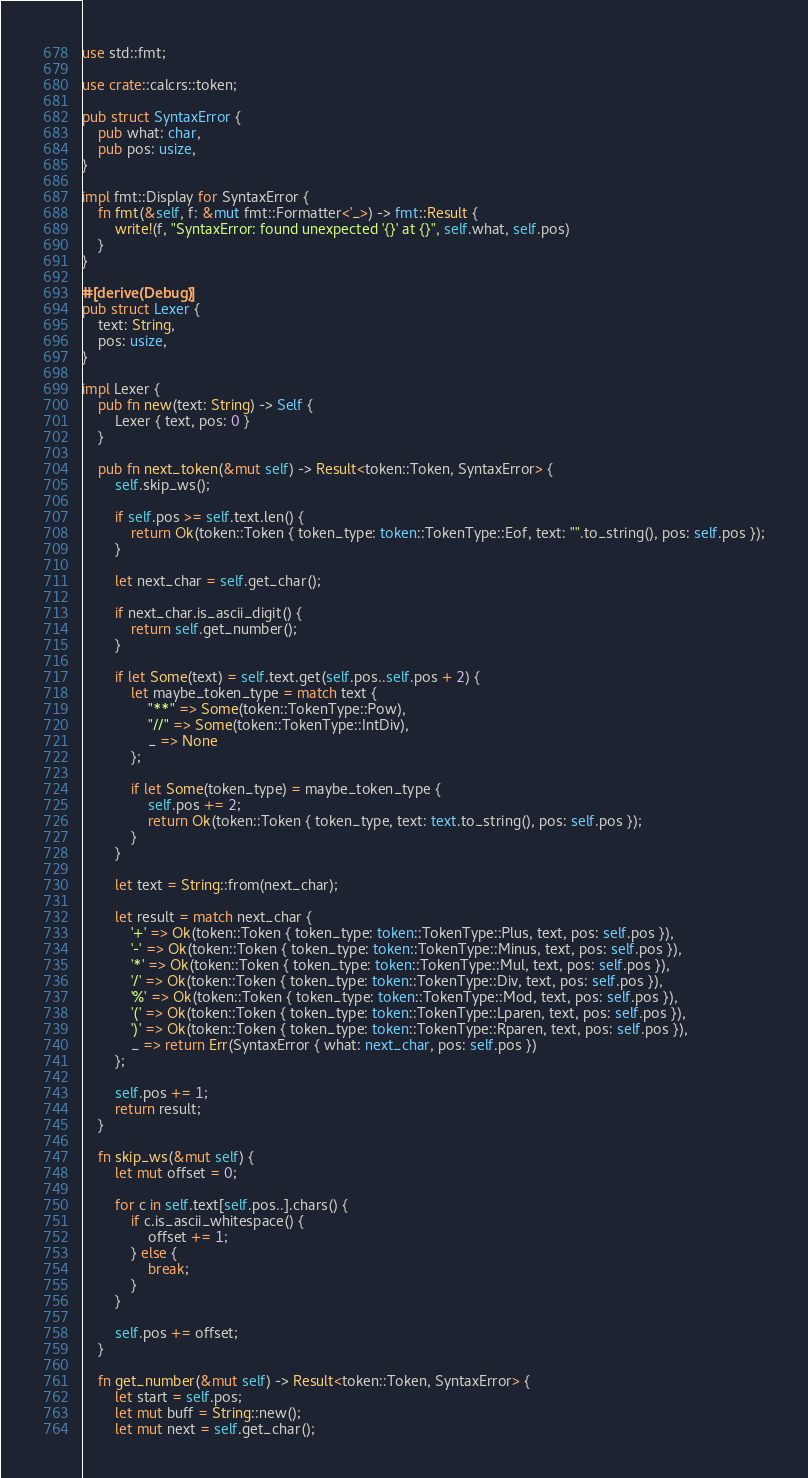Convert code to text. <code><loc_0><loc_0><loc_500><loc_500><_Rust_>use std::fmt;

use crate::calcrs::token;

pub struct SyntaxError {
    pub what: char,
    pub pos: usize,
}

impl fmt::Display for SyntaxError {
    fn fmt(&self, f: &mut fmt::Formatter<'_>) -> fmt::Result {
        write!(f, "SyntaxError: found unexpected '{}' at {}", self.what, self.pos)
    }
}

#[derive(Debug)]
pub struct Lexer {
    text: String,
    pos: usize,
}

impl Lexer {
    pub fn new(text: String) -> Self {
        Lexer { text, pos: 0 }
    }

    pub fn next_token(&mut self) -> Result<token::Token, SyntaxError> {
        self.skip_ws();

        if self.pos >= self.text.len() {
            return Ok(token::Token { token_type: token::TokenType::Eof, text: "".to_string(), pos: self.pos });
        }

        let next_char = self.get_char();

        if next_char.is_ascii_digit() {
            return self.get_number();
        }

        if let Some(text) = self.text.get(self.pos..self.pos + 2) {
            let maybe_token_type = match text {
                "**" => Some(token::TokenType::Pow),
                "//" => Some(token::TokenType::IntDiv),
                _ => None
            };

            if let Some(token_type) = maybe_token_type {
                self.pos += 2;
                return Ok(token::Token { token_type, text: text.to_string(), pos: self.pos });
            }
        }

        let text = String::from(next_char);

        let result = match next_char {
            '+' => Ok(token::Token { token_type: token::TokenType::Plus, text, pos: self.pos }),
            '-' => Ok(token::Token { token_type: token::TokenType::Minus, text, pos: self.pos }),
            '*' => Ok(token::Token { token_type: token::TokenType::Mul, text, pos: self.pos }),
            '/' => Ok(token::Token { token_type: token::TokenType::Div, text, pos: self.pos }),
            '%' => Ok(token::Token { token_type: token::TokenType::Mod, text, pos: self.pos }),
            '(' => Ok(token::Token { token_type: token::TokenType::Lparen, text, pos: self.pos }),
            ')' => Ok(token::Token { token_type: token::TokenType::Rparen, text, pos: self.pos }),
            _ => return Err(SyntaxError { what: next_char, pos: self.pos })
        };

        self.pos += 1;
        return result;
    }

    fn skip_ws(&mut self) {
        let mut offset = 0;

        for c in self.text[self.pos..].chars() {
            if c.is_ascii_whitespace() {
                offset += 1;
            } else {
                break;
            }
        }

        self.pos += offset;
    }

    fn get_number(&mut self) -> Result<token::Token, SyntaxError> {
        let start = self.pos;
        let mut buff = String::new();
        let mut next = self.get_char();
</code> 